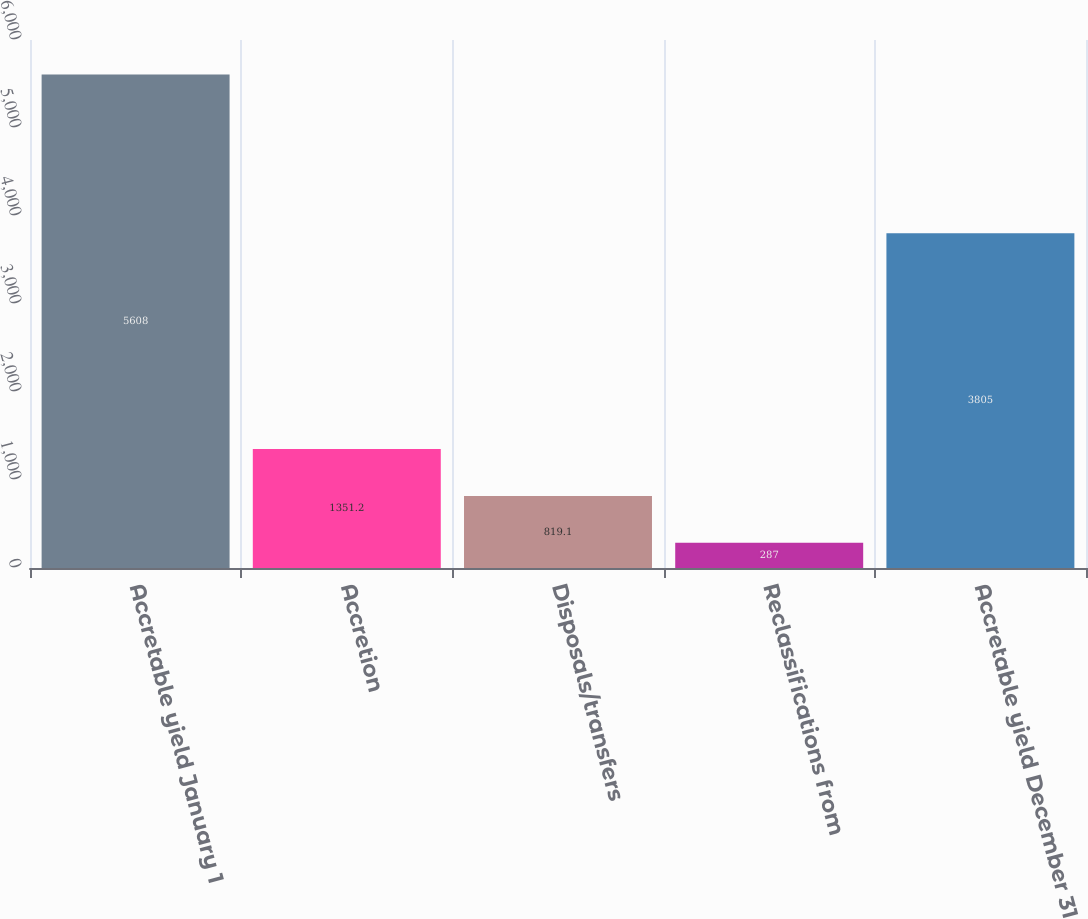<chart> <loc_0><loc_0><loc_500><loc_500><bar_chart><fcel>Accretable yield January 1<fcel>Accretion<fcel>Disposals/transfers<fcel>Reclassifications from<fcel>Accretable yield December 31<nl><fcel>5608<fcel>1351.2<fcel>819.1<fcel>287<fcel>3805<nl></chart> 